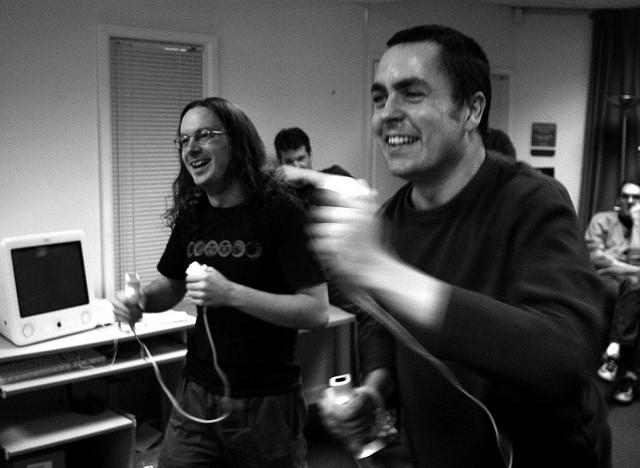Are the men wearing watches?
Concise answer only. No. Is someone wearing glasses?
Quick response, please. Yes. Are the men playing a video game?
Write a very short answer. Yes. Does the man look angry?
Be succinct. No. Are these men together?
Write a very short answer. Yes. What is on the table to the left of the men?
Be succinct. Monitor. What color is the photo?
Short answer required. Black and white. Is this person clean shaven?
Write a very short answer. Yes. What event is this?
Give a very brief answer. Gaming. 